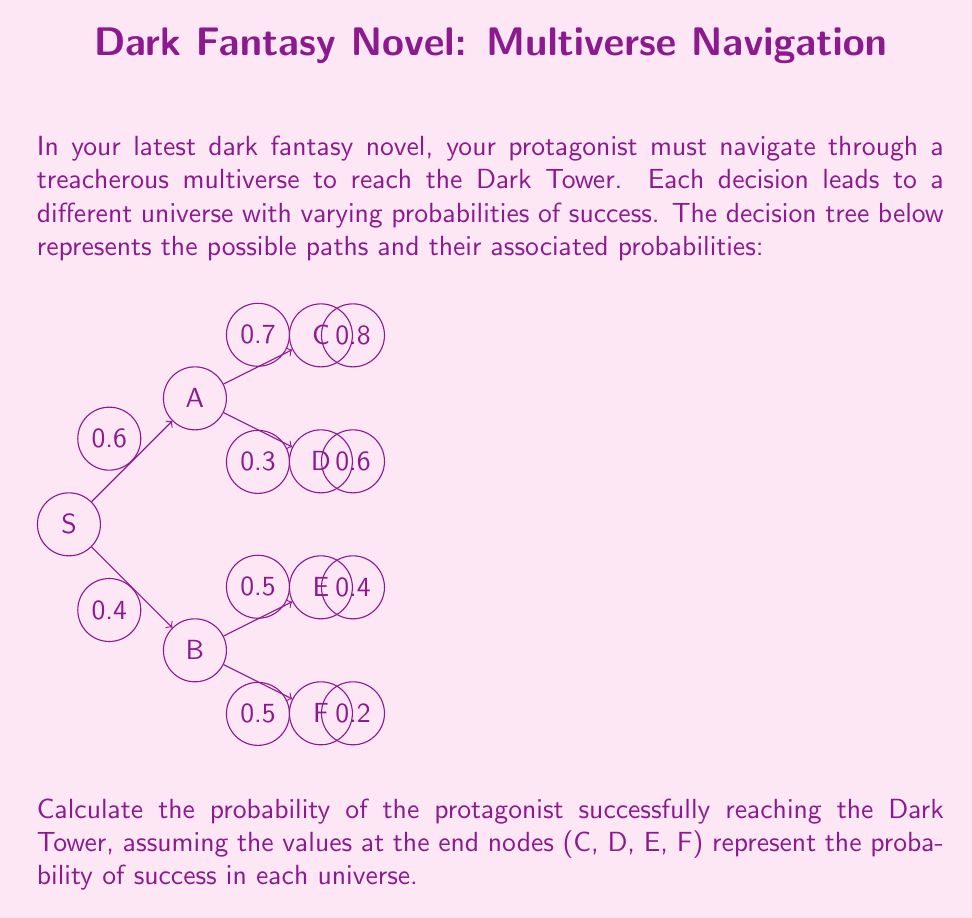Solve this math problem. To solve this problem, we'll use the concept of expected value in decision trees. We'll work backwards from the end nodes to the start node, calculating the probability of success at each step.

Step 1: Analyze the upper branch (Node A)
- Probability of reaching A: 0.6
- From A to C: 0.7 * 0.8 = 0.56
- From A to D: 0.3 * 0.6 = 0.18
- Total probability of success through A: 0.56 + 0.18 = 0.74
- Expected value at A: 0.74

Step 2: Analyze the lower branch (Node B)
- Probability of reaching B: 0.4
- From B to E: 0.5 * 0.4 = 0.2
- From B to F: 0.5 * 0.2 = 0.1
- Total probability of success through B: 0.2 + 0.1 = 0.3
- Expected value at B: 0.3

Step 3: Calculate the overall probability of success
- From start node S to A: 0.6 * 0.74 = 0.444
- From start node S to B: 0.4 * 0.3 = 0.12
- Total probability of success: 0.444 + 0.12 = 0.564

Therefore, the probability of the protagonist successfully reaching the Dark Tower is 0.564 or 56.4%.
Answer: $0.564$ 